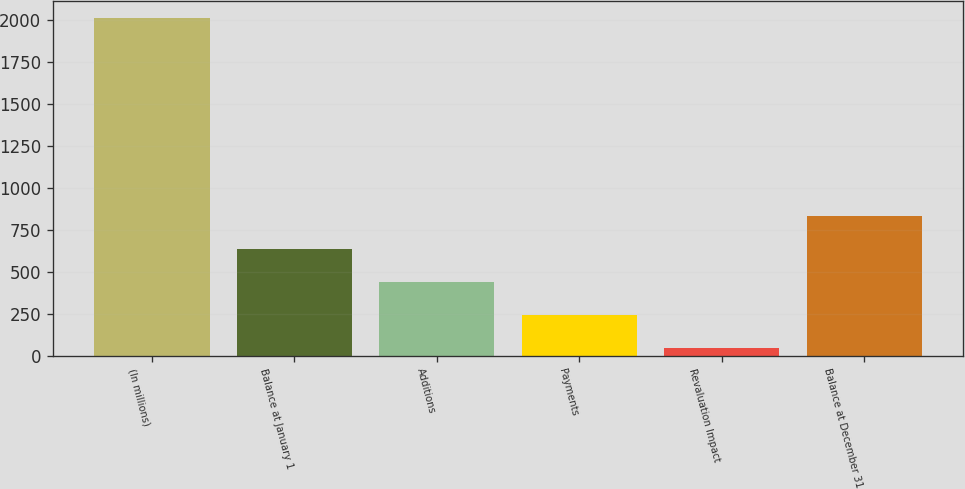<chart> <loc_0><loc_0><loc_500><loc_500><bar_chart><fcel>(In millions)<fcel>Balance at January 1<fcel>Additions<fcel>Payments<fcel>Revaluation Impact<fcel>Balance at December 31<nl><fcel>2015<fcel>636<fcel>439<fcel>242<fcel>45<fcel>833<nl></chart> 